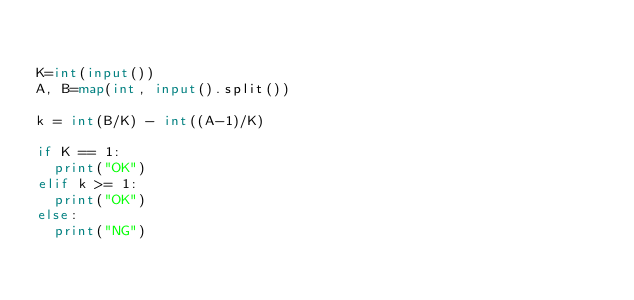Convert code to text. <code><loc_0><loc_0><loc_500><loc_500><_Python_>

K=int(input())
A, B=map(int, input().split())

k = int(B/K) - int((A-1)/K) 

if K == 1:
	print("OK")
elif k >= 1:
	print("OK")
else:
	print("NG")

</code> 